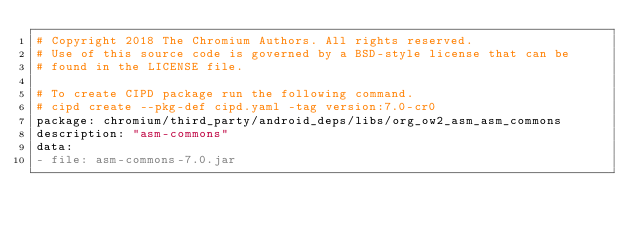Convert code to text. <code><loc_0><loc_0><loc_500><loc_500><_YAML_># Copyright 2018 The Chromium Authors. All rights reserved.
# Use of this source code is governed by a BSD-style license that can be
# found in the LICENSE file.

# To create CIPD package run the following command.
# cipd create --pkg-def cipd.yaml -tag version:7.0-cr0
package: chromium/third_party/android_deps/libs/org_ow2_asm_asm_commons
description: "asm-commons"
data:
- file: asm-commons-7.0.jar
</code> 